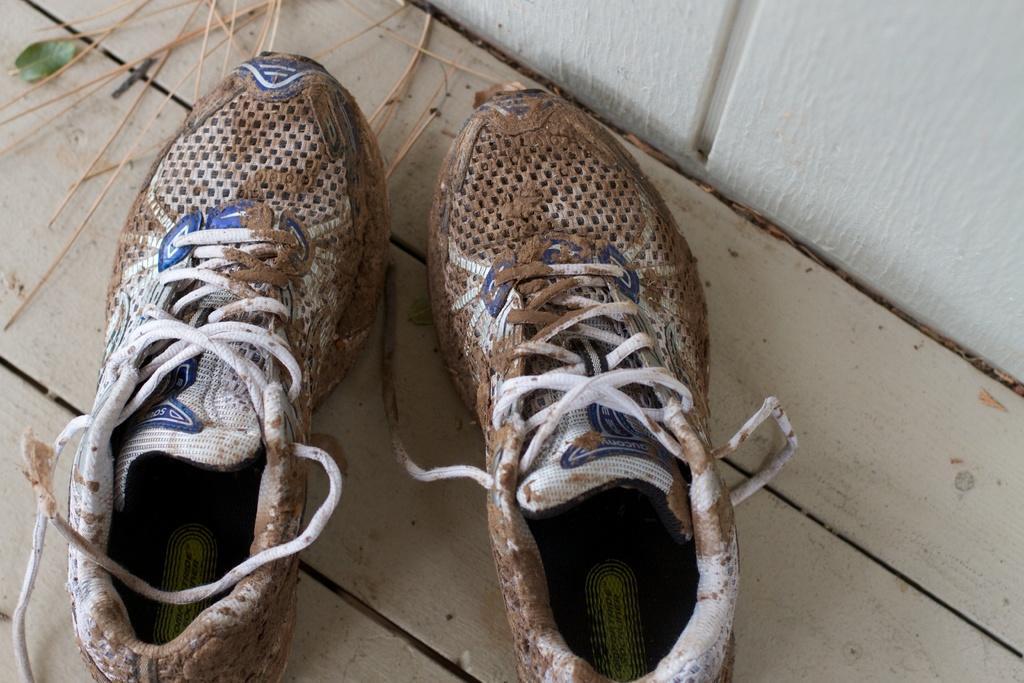Please provide a concise description of this image. In the foreground of this image, there are muddy shoes on the wooden surface. In the background, there is a white wall and we can also see few sticks on the top. 